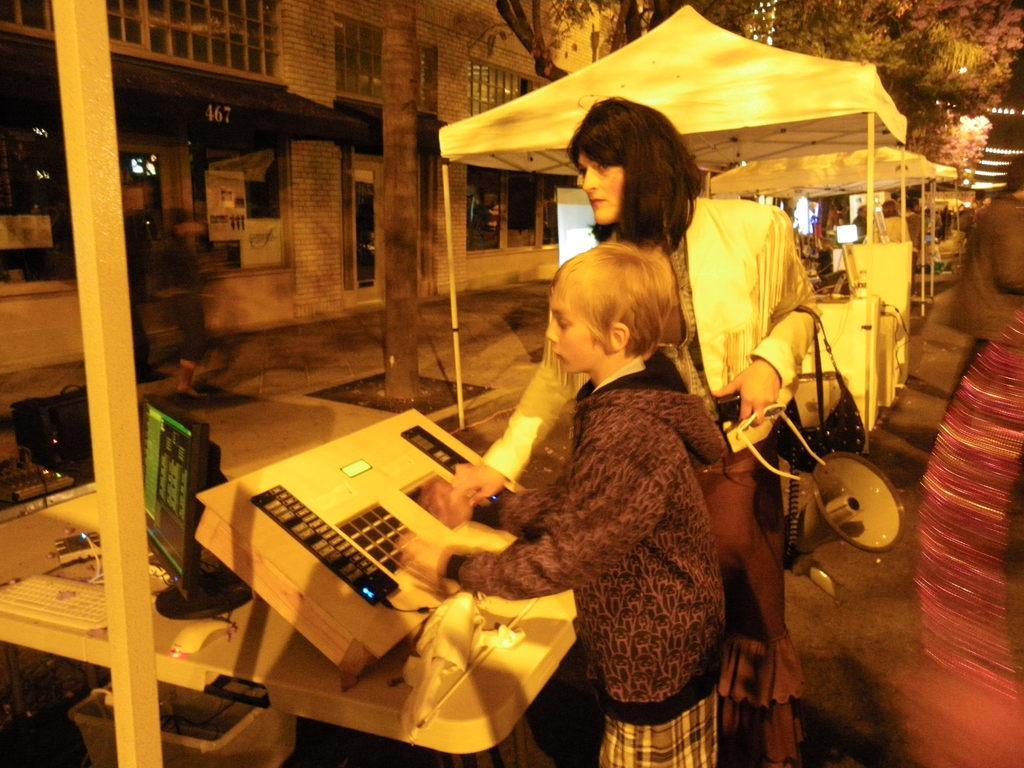Could you give a brief overview of what you see in this image? In this picture we can observe a child standing in front of a device placed on the white color table. We can observe a monitor and a pole on the left side. There is a woman holding a loudspeaker in her hand. In the background we can observe white color tint. On the left side there is a building and a tree. In the background there are some lights and trees. 